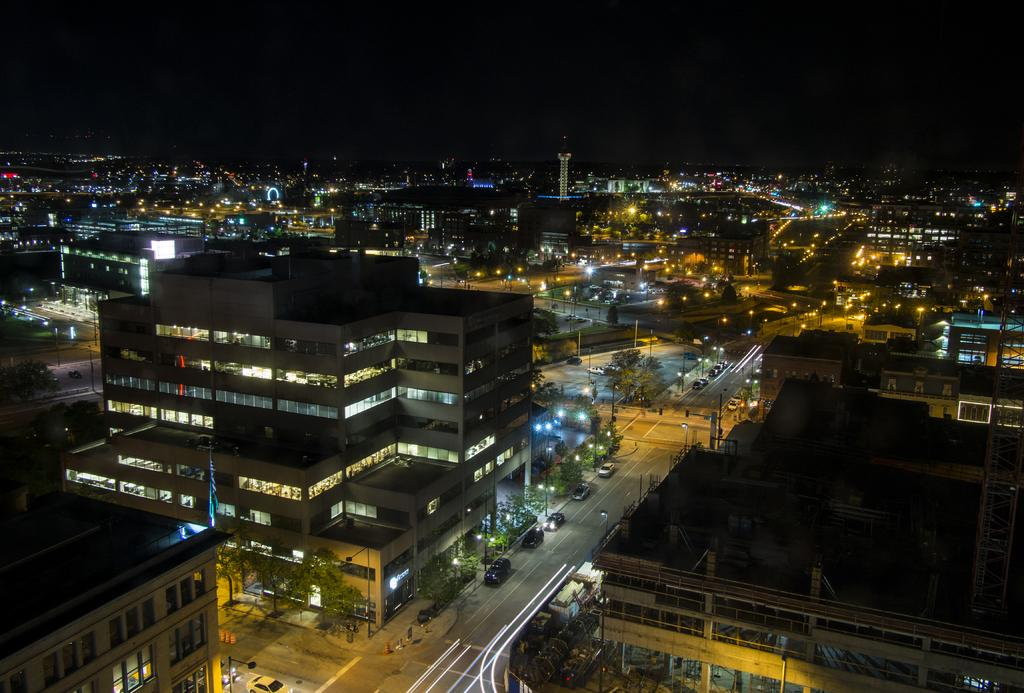What type of structures can be seen in the image? There are buildings in the image. What other natural elements are present in the image? There are trees in the image. Are there any artificial light sources visible in the image? Yes, there are lights in the image. What is happening on the road in front of the building? There are vehicles on the road in front of the building. Can you tell me how many bears are playing a game in the image? There are no bears or games present in the image. 